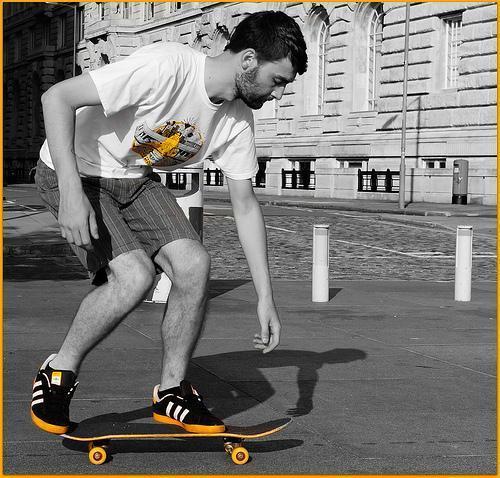How many of the skater's shoes are red?
Give a very brief answer. 0. 